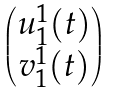Convert formula to latex. <formula><loc_0><loc_0><loc_500><loc_500>\begin{pmatrix} u _ { 1 } ^ { 1 } ( t ) \\ v _ { 1 } ^ { 1 } ( t ) \end{pmatrix}</formula> 